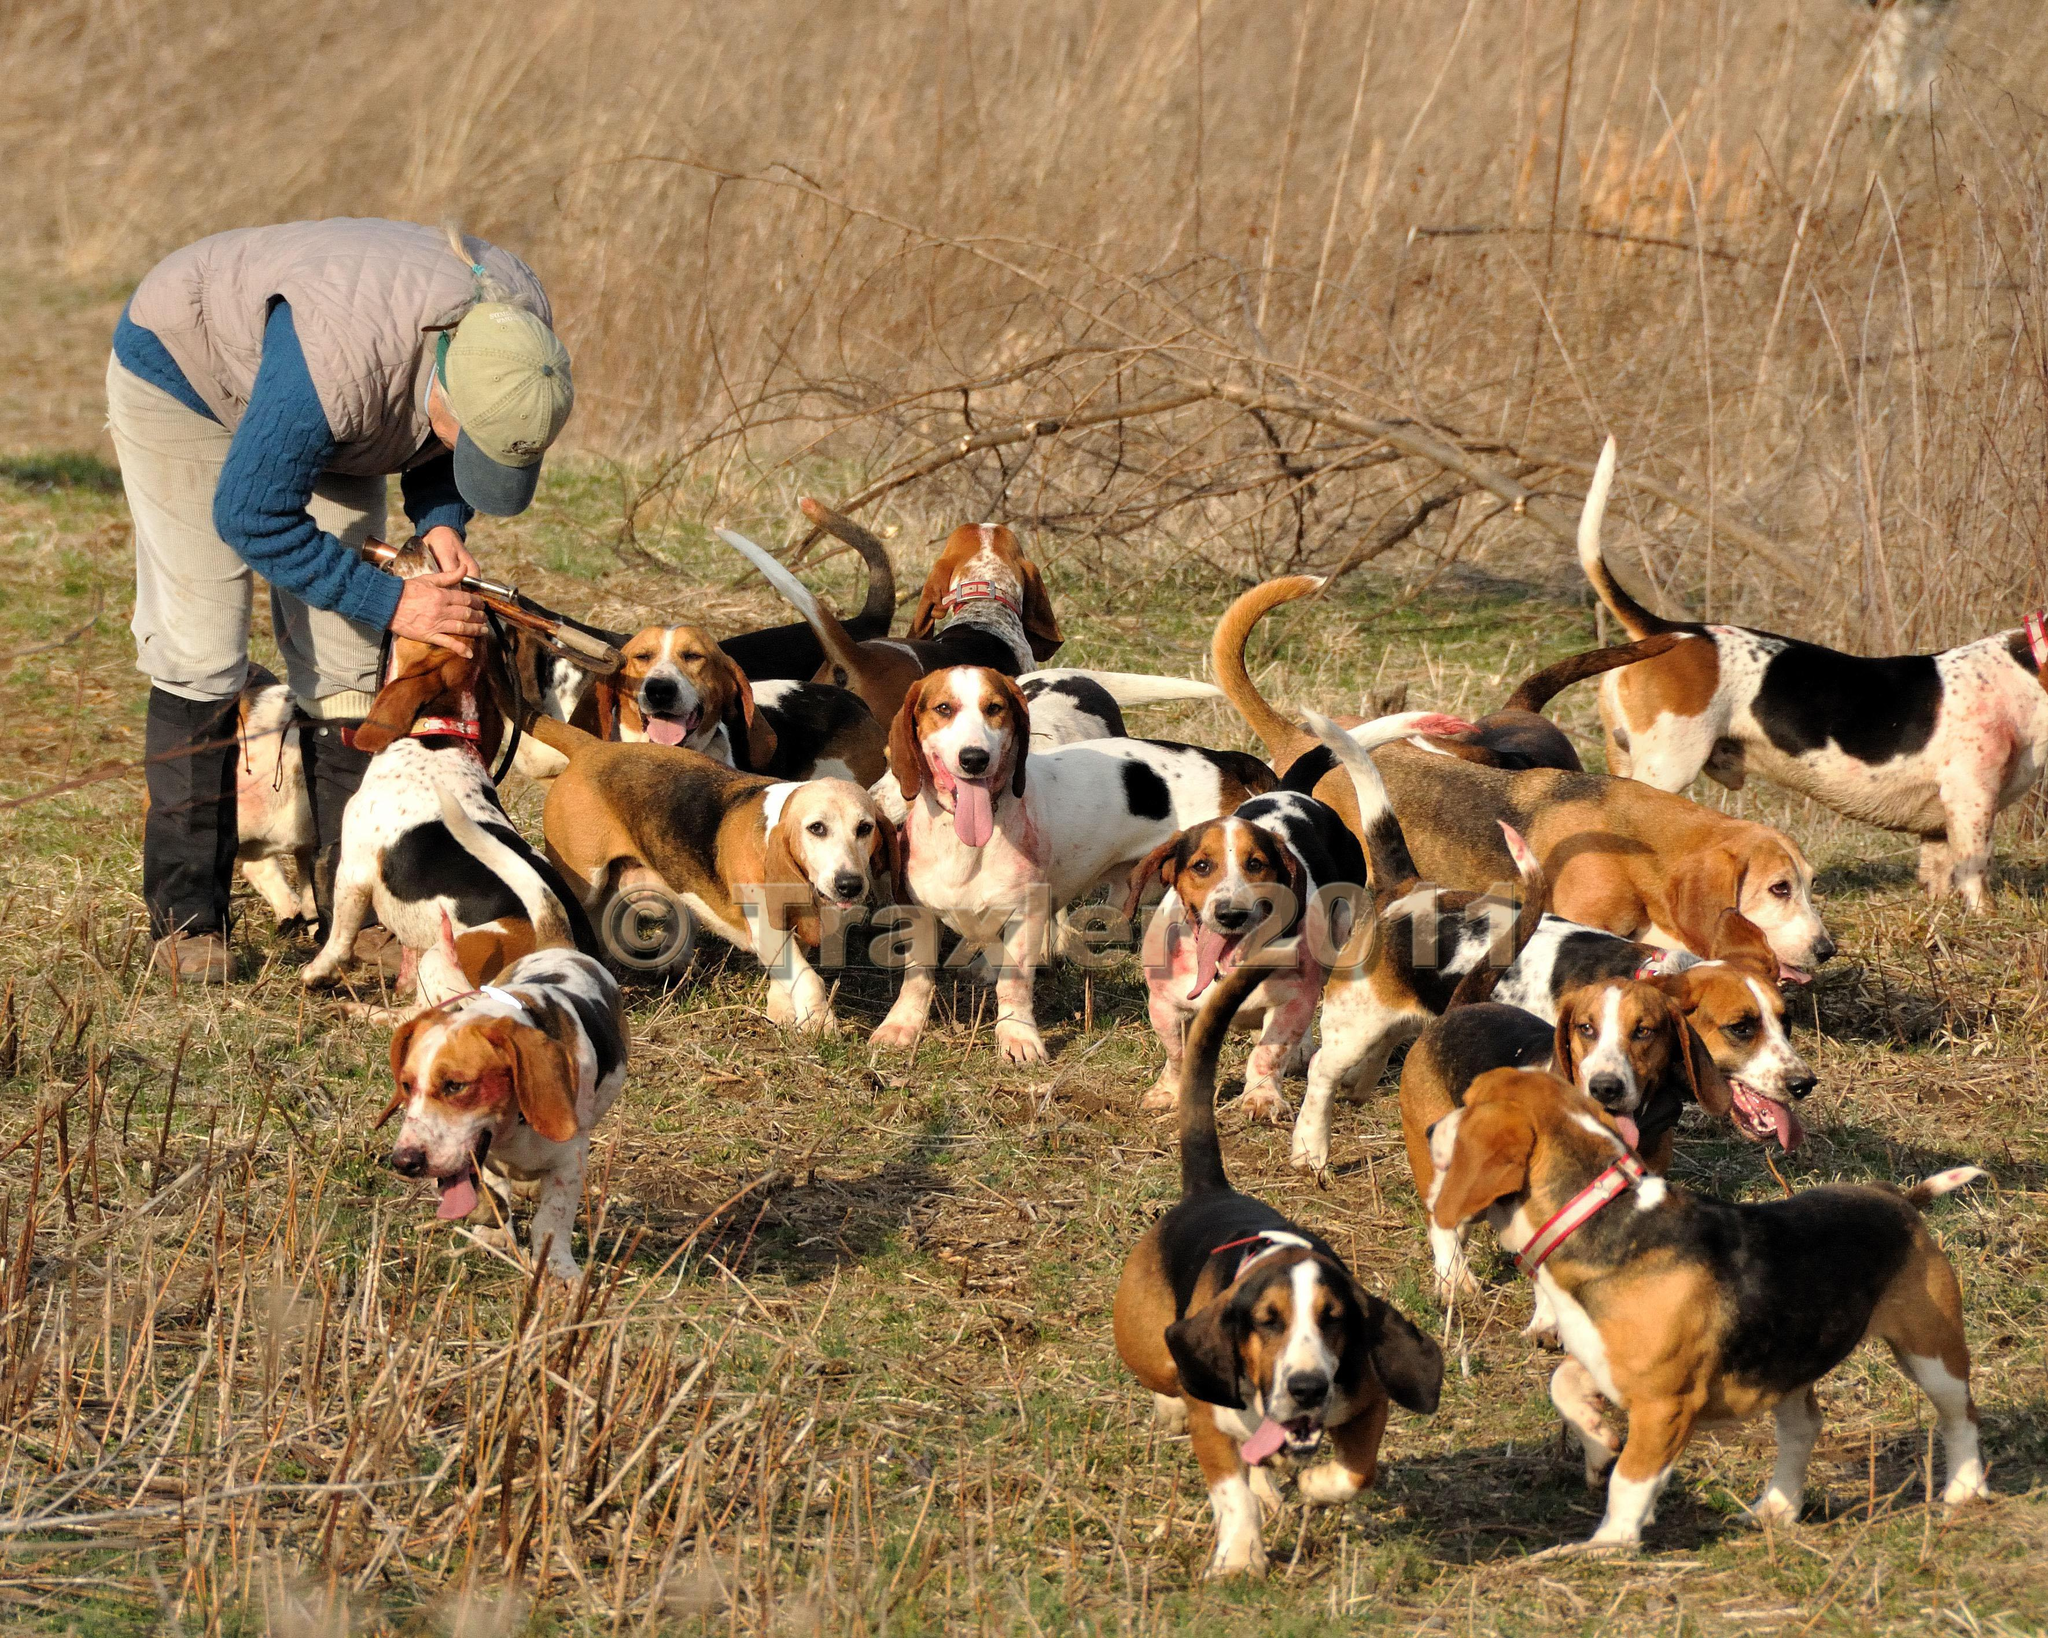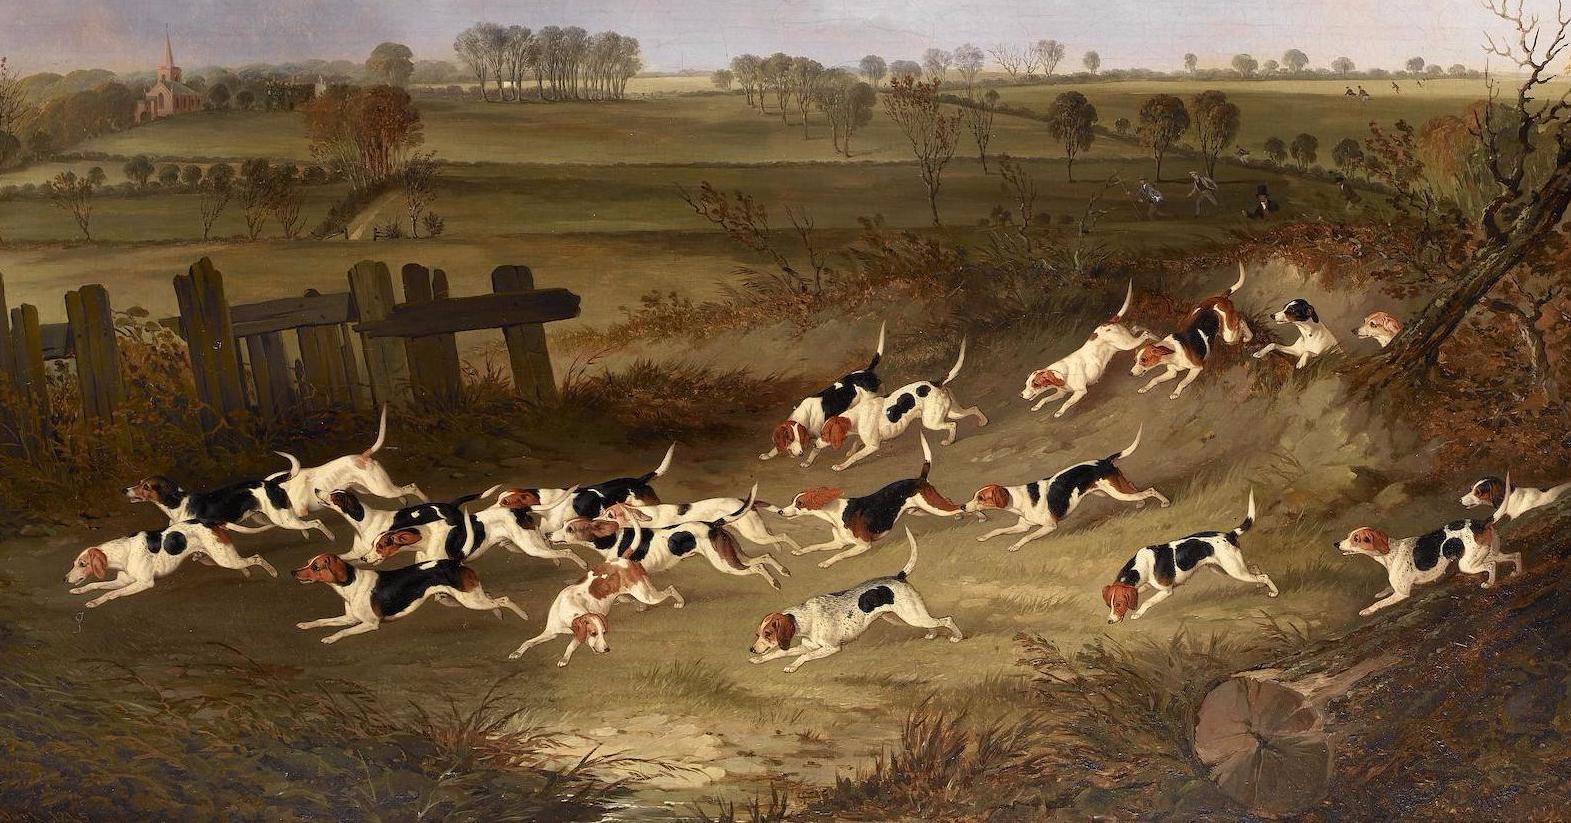The first image is the image on the left, the second image is the image on the right. For the images displayed, is the sentence "A man is with a group of dogs in a grassy area in the image on the left." factually correct? Answer yes or no. Yes. 